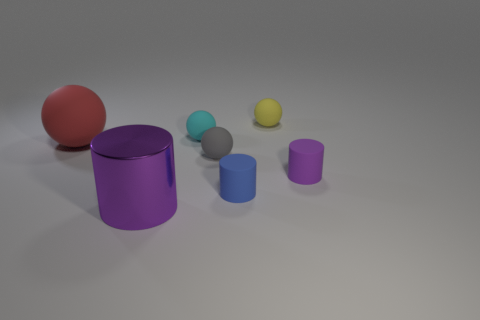Is there anything else that has the same material as the large cylinder?
Provide a succinct answer. No. The big cylinder is what color?
Make the answer very short. Purple. How many other big things have the same shape as the purple metallic thing?
Offer a very short reply. 0. There is a rubber cylinder that is the same size as the purple rubber object; what color is it?
Provide a short and direct response. Blue. Are any big matte balls visible?
Your response must be concise. Yes. There is a small matte object that is right of the yellow matte thing; what shape is it?
Offer a terse response. Cylinder. What number of balls are on the right side of the big red thing and in front of the yellow sphere?
Your answer should be very brief. 2. Are there any small cyan spheres that have the same material as the small yellow sphere?
Give a very brief answer. Yes. What size is the rubber thing that is the same color as the metallic thing?
Offer a terse response. Small. How many blocks are either small red objects or big red objects?
Offer a terse response. 0. 